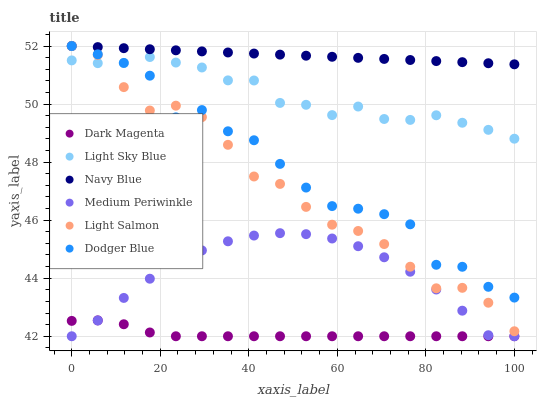Does Dark Magenta have the minimum area under the curve?
Answer yes or no. Yes. Does Navy Blue have the maximum area under the curve?
Answer yes or no. Yes. Does Navy Blue have the minimum area under the curve?
Answer yes or no. No. Does Dark Magenta have the maximum area under the curve?
Answer yes or no. No. Is Navy Blue the smoothest?
Answer yes or no. Yes. Is Dodger Blue the roughest?
Answer yes or no. Yes. Is Dark Magenta the smoothest?
Answer yes or no. No. Is Dark Magenta the roughest?
Answer yes or no. No. Does Dark Magenta have the lowest value?
Answer yes or no. Yes. Does Navy Blue have the lowest value?
Answer yes or no. No. Does Dodger Blue have the highest value?
Answer yes or no. Yes. Does Dark Magenta have the highest value?
Answer yes or no. No. Is Medium Periwinkle less than Dodger Blue?
Answer yes or no. Yes. Is Dodger Blue greater than Dark Magenta?
Answer yes or no. Yes. Does Navy Blue intersect Light Salmon?
Answer yes or no. Yes. Is Navy Blue less than Light Salmon?
Answer yes or no. No. Is Navy Blue greater than Light Salmon?
Answer yes or no. No. Does Medium Periwinkle intersect Dodger Blue?
Answer yes or no. No. 